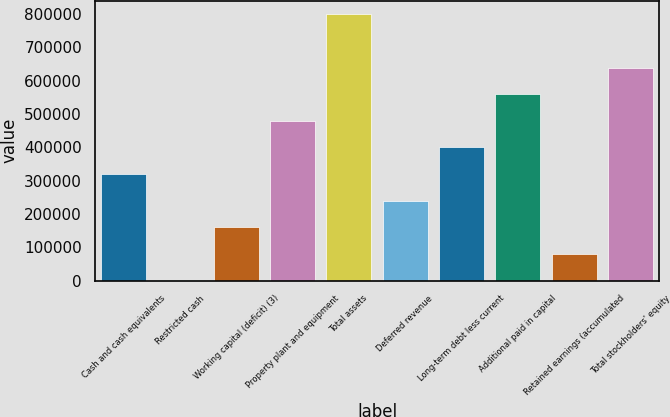Convert chart. <chart><loc_0><loc_0><loc_500><loc_500><bar_chart><fcel>Cash and cash equivalents<fcel>Restricted cash<fcel>Working capital (deficit) (3)<fcel>Property plant and equipment<fcel>Total assets<fcel>Deferred revenue<fcel>Long-term debt less current<fcel>Additional paid in capital<fcel>Retained earnings (accumulated<fcel>Total stockholders' equity<nl><fcel>319799<fcel>371<fcel>160085<fcel>479514<fcel>798942<fcel>239942<fcel>399656<fcel>559371<fcel>80228.1<fcel>639228<nl></chart> 